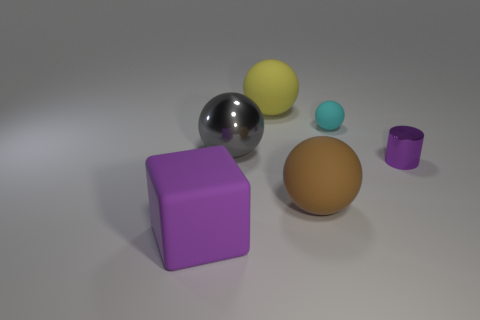Subtract all red balls. Subtract all red cylinders. How many balls are left? 4 Add 2 cylinders. How many objects exist? 8 Subtract all balls. How many objects are left? 2 Add 5 big metallic objects. How many big metallic objects exist? 6 Subtract 0 yellow cylinders. How many objects are left? 6 Subtract all tiny brown balls. Subtract all large yellow spheres. How many objects are left? 5 Add 6 big yellow balls. How many big yellow balls are left? 7 